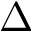<formula> <loc_0><loc_0><loc_500><loc_500>\Delta</formula> 